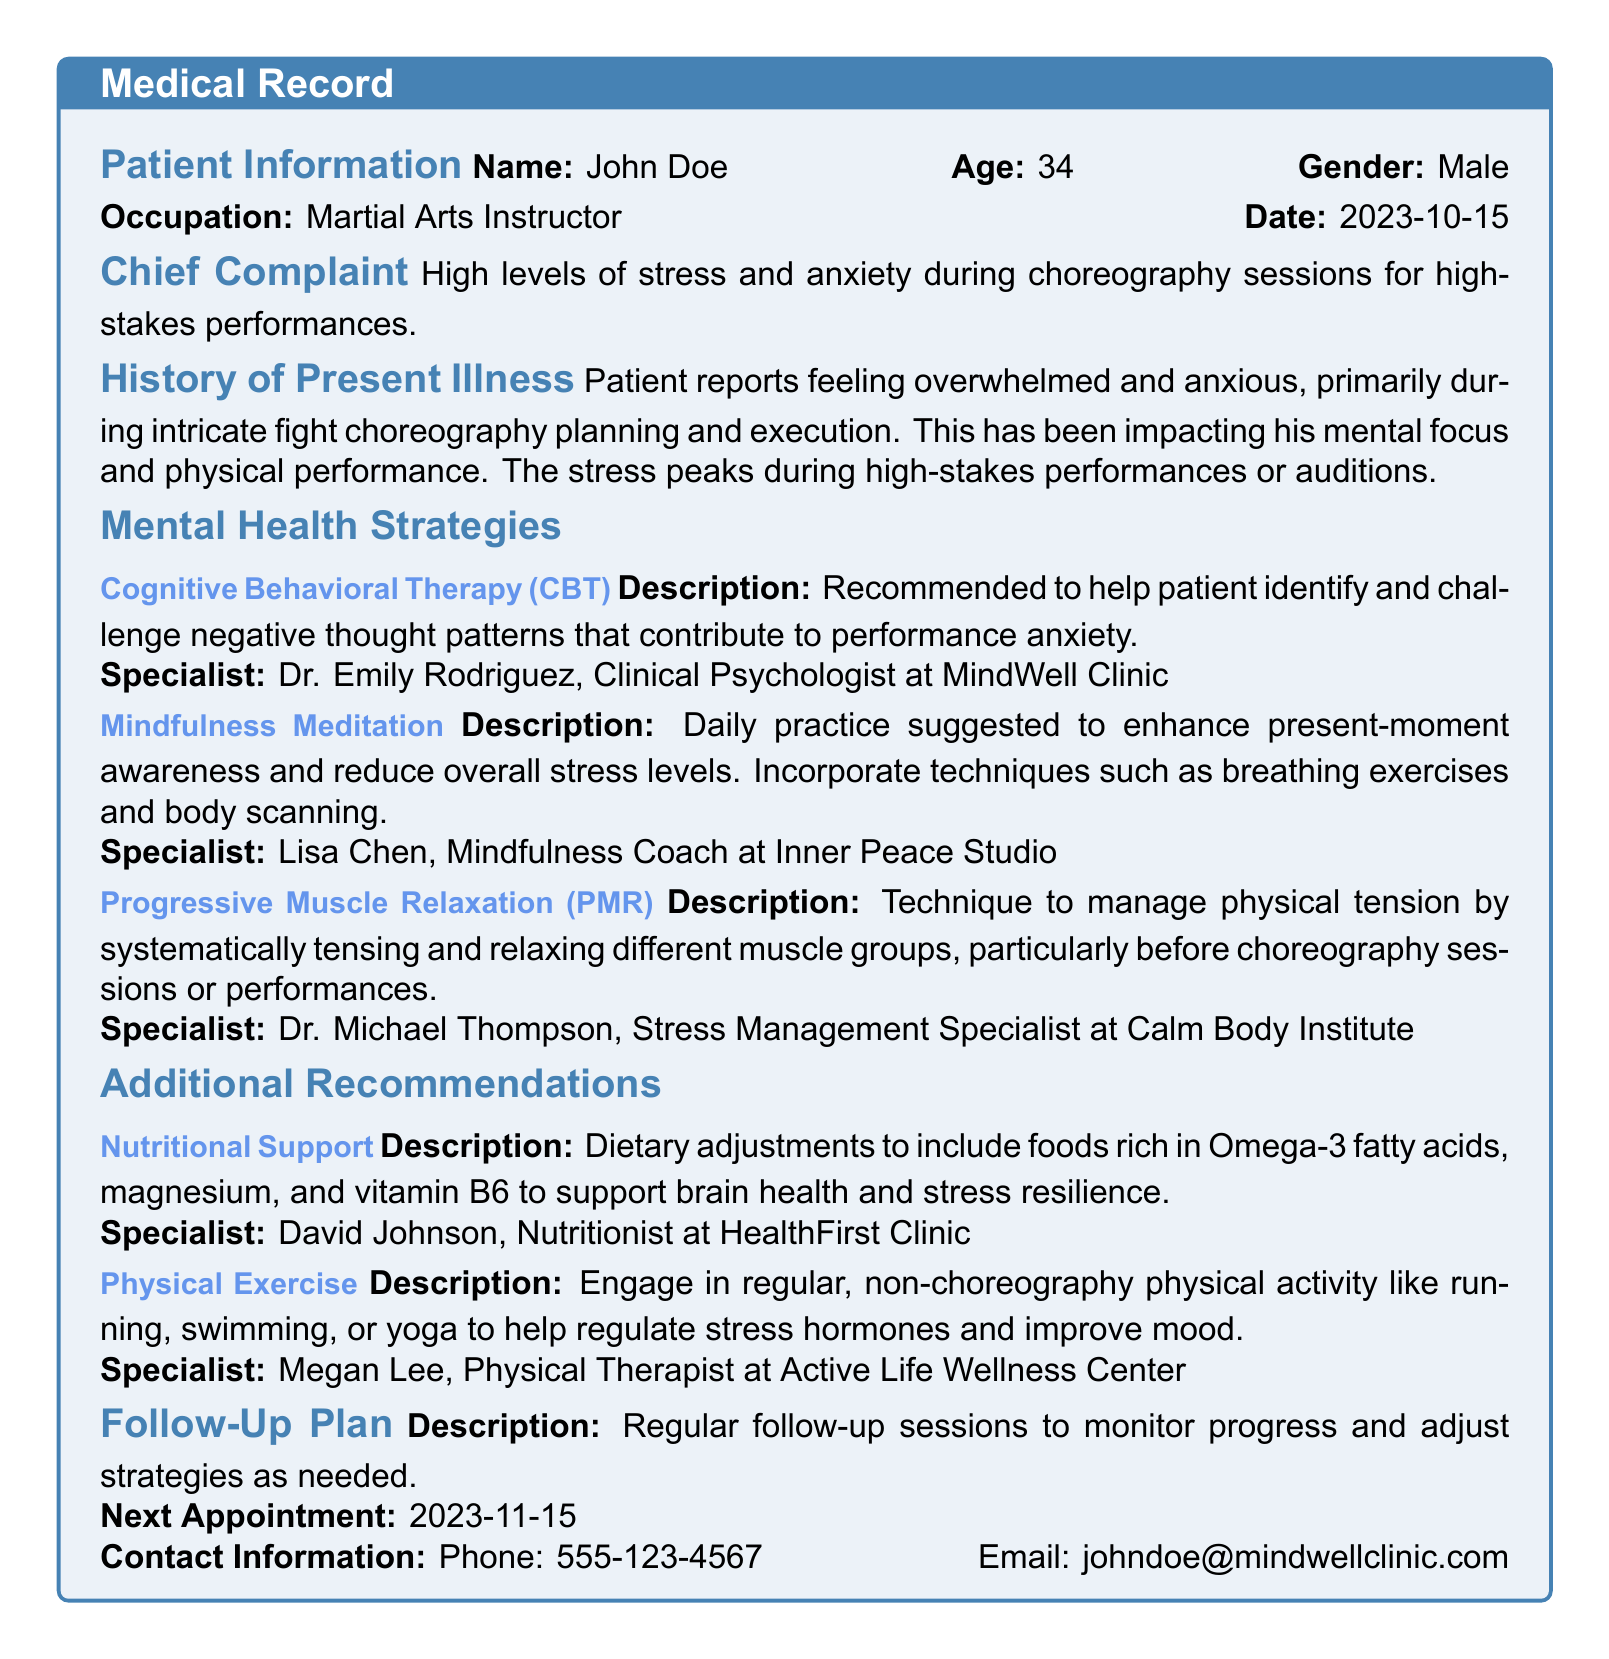What is the patient’s name? The name of the patient is stated in the Patient Information section of the document.
Answer: John Doe What is the patient’s age? The age of the patient is mentioned in the Patient Information section.
Answer: 34 What specialist is recommended for Cognitive Behavioral Therapy? The document lists the specialist associated with Cognitive Behavioral Therapy in the Mental Health Strategies section.
Answer: Dr. Emily Rodriguez What technique is advised for managing physical tension? The technique mentioned in the Mental Health Strategies section for managing physical tension is specified.
Answer: Progressive Muscle Relaxation What dietary adjustments are recommended? The Additional Recommendations section includes information about dietary adjustments for stress resilience.
Answer: Foods rich in Omega-3 fatty acids, magnesium, and vitamin B6 When is the next appointment scheduled? The follow-up plan specifies the date of the next appointment.
Answer: 2023-11-15 What type of exercise is encouraged besides choreography? The Additional Recommendations section points to the type of exercise the patient is encouraged to do.
Answer: Running, swimming, or yoga What is the chief complaint of the patient? The Chief Complaint section provides information about the patient’s primary issue.
Answer: High levels of stress and anxiety during choreography sessions 